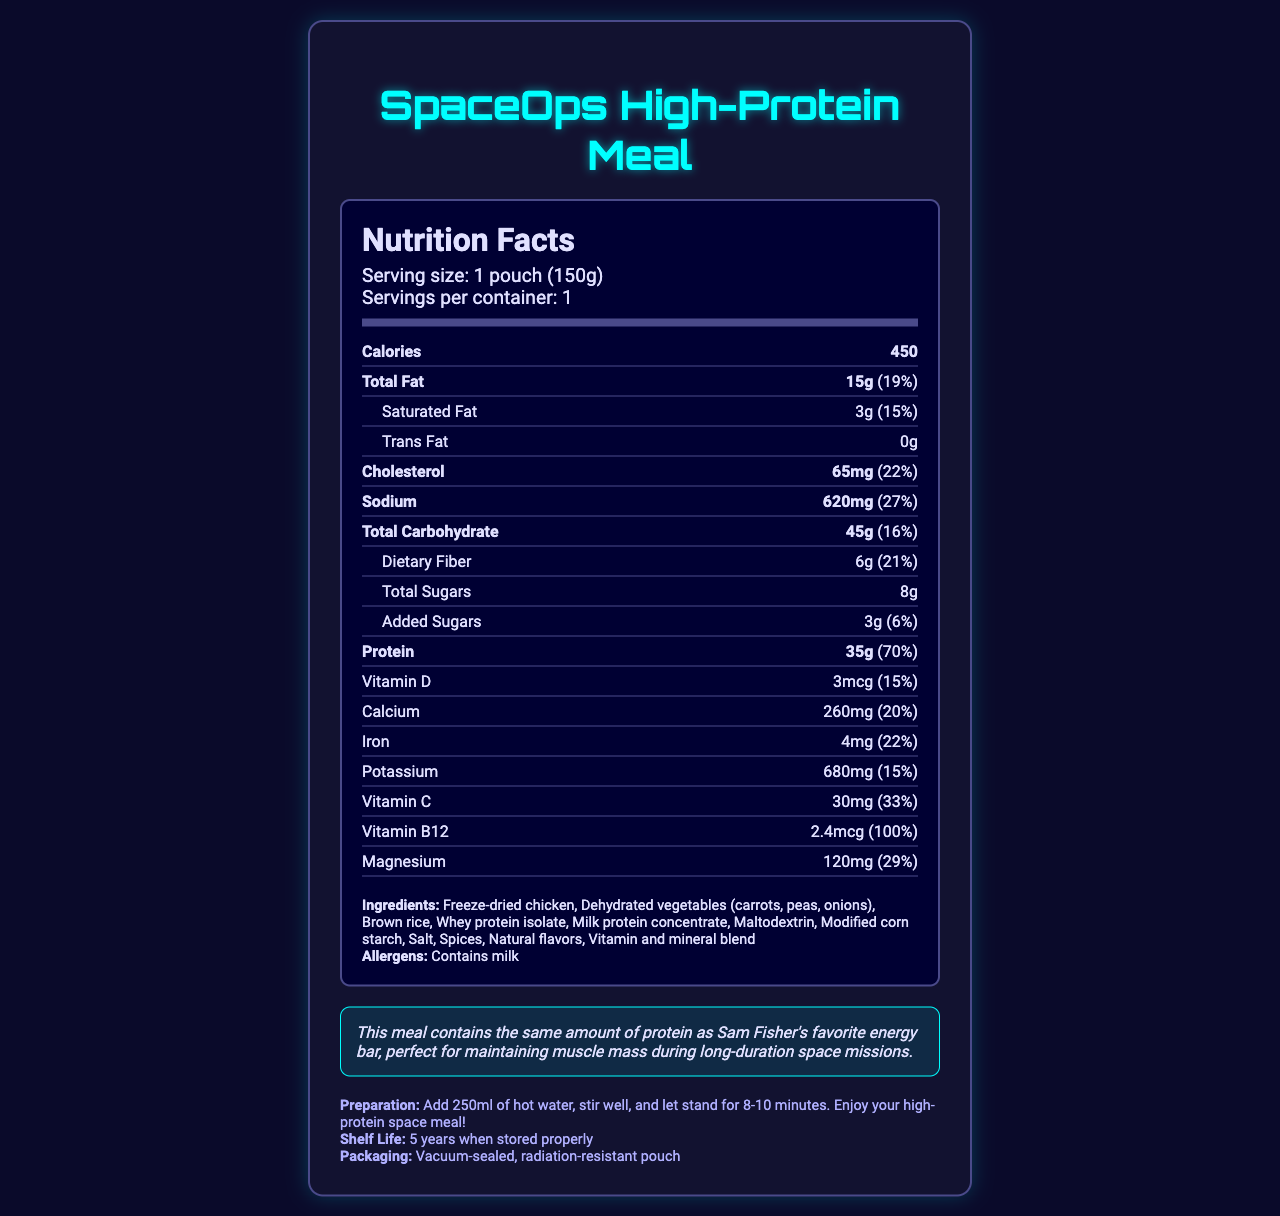what is the serving size of the SpaceOps High-Protein Meal? The serving size is explicitly listed as "1 pouch (150g)" in the document.
Answer: 1 pouch (150g) how many calories are in one serving? The document states that the calories per serving are 450.
Answer: 450 how much protein is in the SpaceOps High-Protein Meal, and what percentage of the daily value does it provide? The document mentions that the meal contains 35g of protein, which is 70% of the daily value.
Answer: 35g, 70% what is the total amount of fat in grams per serving? The document specifies that there are 15g of total fat per serving.
Answer: 15g what percentage of the daily value is the cholesterol content? The cholesterol content is listed as 22% of the daily value.
Answer: 22% which vitamin has a daily value percentage of 33%? According to the document, Vitamin C has a daily value percentage of 33%.
Answer: Vitamin C how much dietary fiber is in the SpaceOps High-Protein Meal? The document states that there are 6g of dietary fiber in the meal.
Answer: 6g what is the sodium content in milligrams and its daily value percentage? The sodium content is explicitly listed as 620mg, which is 27% of the daily value.
Answer: 620mg, 27% which ingredient is listed first in the ingredients list? The first ingredient listed is "Freeze-dried chicken."
Answer: Freeze-dried chicken what preparation steps are necessary to enjoy the high-protein space meal? The preparation instructions specify adding 250ml of hot water, stirring well, and letting it stand for 8-10 minutes.
Answer: Add 250ml of hot water, stir well, and let stand for 8-10 minutes which nutrient has the highest daily value percentage? A. Protein B. Vitamin B12 C. Iron D. Calcium The document shows that Vitamin B12 has a daily value percentage of 100%, which is the highest among the listed nutrients.
Answer: B. Vitamin B12 what is the total carbohydrate content per serving? A. 45g B. 50g C. 35g D. 25g The document states that the total carbohydrate content is 45g per serving.
Answer: A. 45g does this meal contain any trans fat? The document specifies that the meal contains 0g of trans fat.
Answer: No are there any allergens listed for the SpaceOps High-Protein Meal? If so, what are they? The document lists "Contains milk" as an allergen.
Answer: Yes, contains milk summarize the main idea of the document. The summary addresses the comprehensive coverage of the nutritional aspects, preparation, and special features of the SpaceOps High-Protein Meal described in the document.
Answer: The document provides detailed nutritional information about the SpaceOps High-Protein Meal, including serving size, caloric content, nutrients, ingredients, allergens, preparation instructions, and additional fun facts. It highlights the high protein content and its suitability for maintaining muscle mass during long-duration space missions. how long is the shelf life of the product when stored properly? The document specifies that the shelf life is 5 years when stored properly.
Answer: 5 years what is the total amount of sugar in one serving? The total sugars are 8g, which includes 3g of added sugars as noted in the document.
Answer: 8g (including 3g of added sugars) why is the meal packaging vacuum-sealed and radiation-resistant? The document mentions that the packaging is vacuum-sealed and radiation-resistant but does not provide the reasons for these features.
Answer: Not enough information 